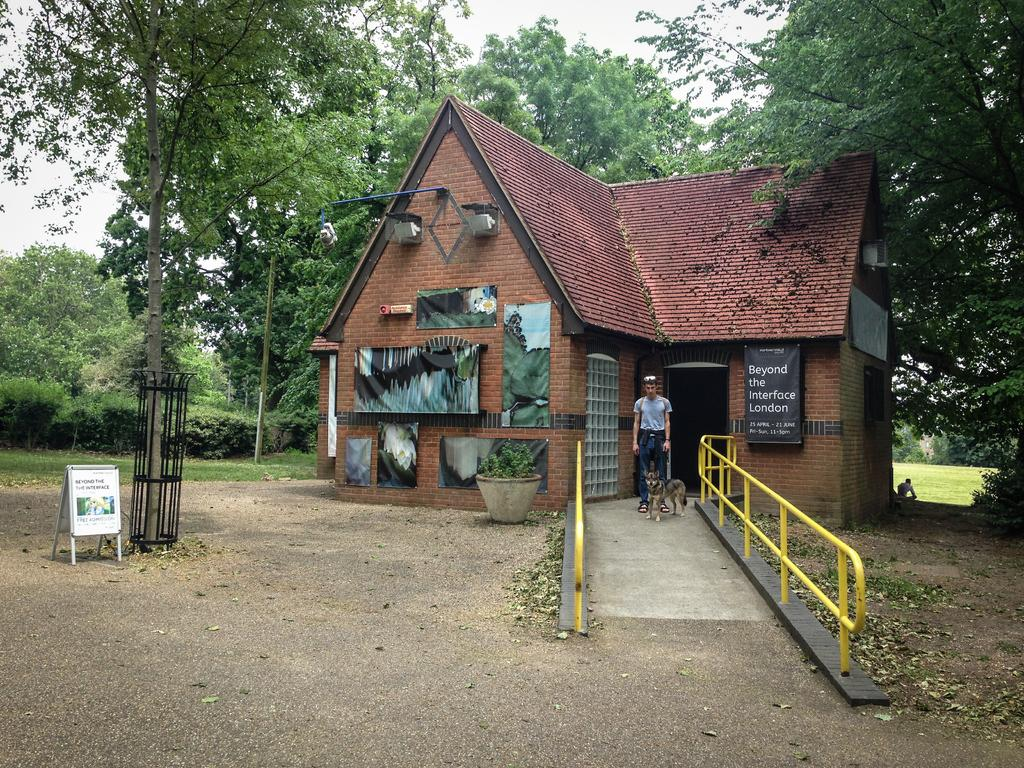Provide a one-sentence caption for the provided image. A sign outside the house states admission is free. 